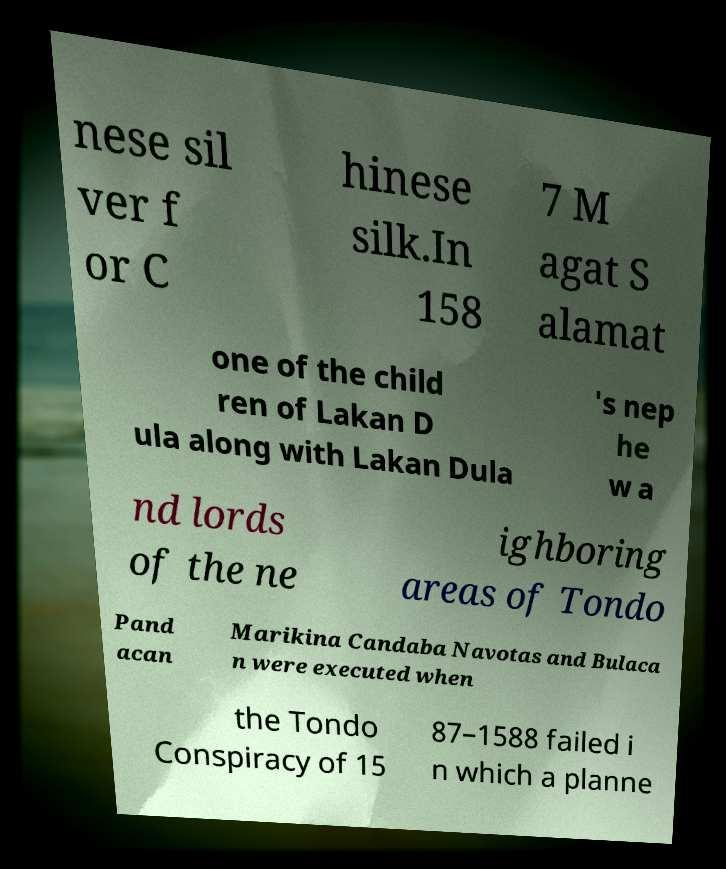Please identify and transcribe the text found in this image. nese sil ver f or C hinese silk.In 158 7 M agat S alamat one of the child ren of Lakan D ula along with Lakan Dula 's nep he w a nd lords of the ne ighboring areas of Tondo Pand acan Marikina Candaba Navotas and Bulaca n were executed when the Tondo Conspiracy of 15 87–1588 failed i n which a planne 